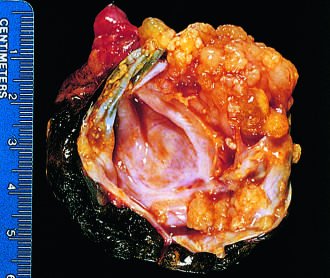s borderline serous cystadenoma opened to display a cyst cavity lined by delicate papillary tumor growths?
Answer the question using a single word or phrase. Yes 